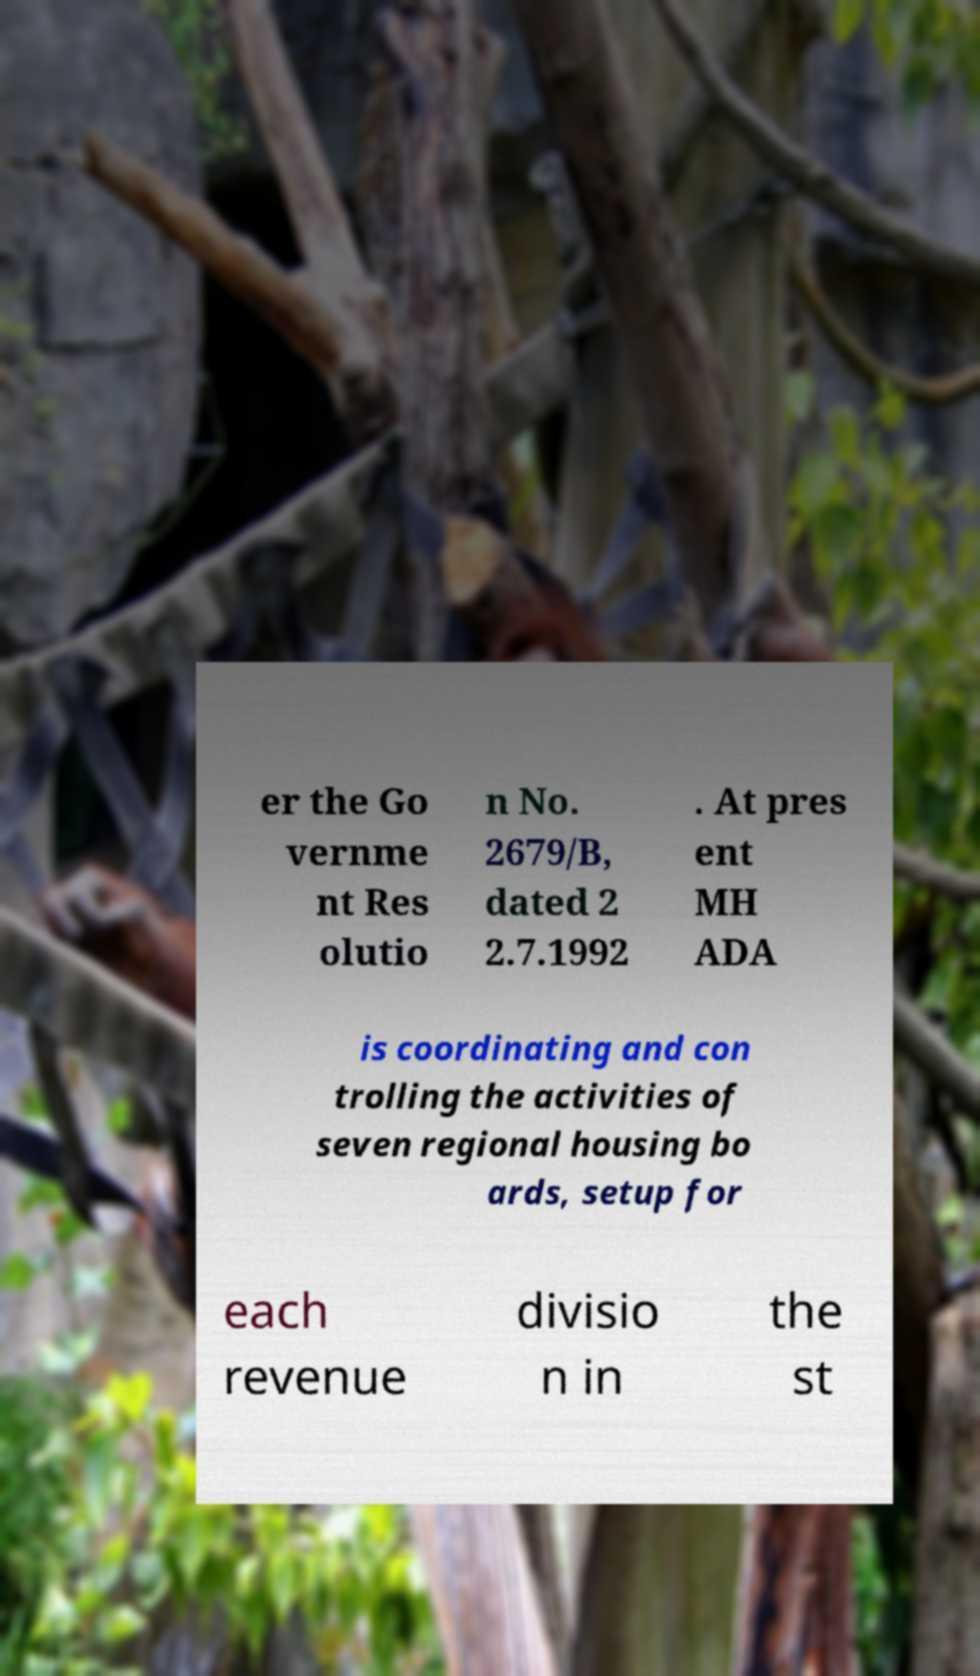For documentation purposes, I need the text within this image transcribed. Could you provide that? er the Go vernme nt Res olutio n No. 2679/B, dated 2 2.7.1992 . At pres ent MH ADA is coordinating and con trolling the activities of seven regional housing bo ards, setup for each revenue divisio n in the st 